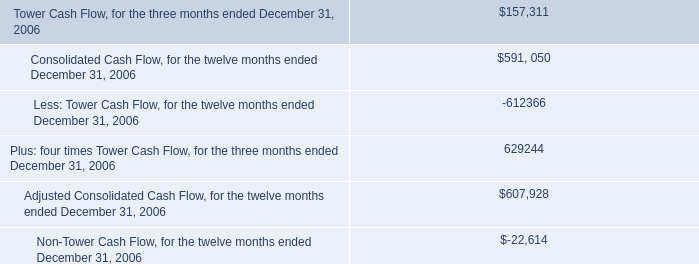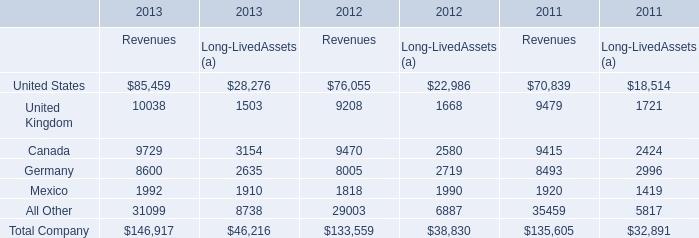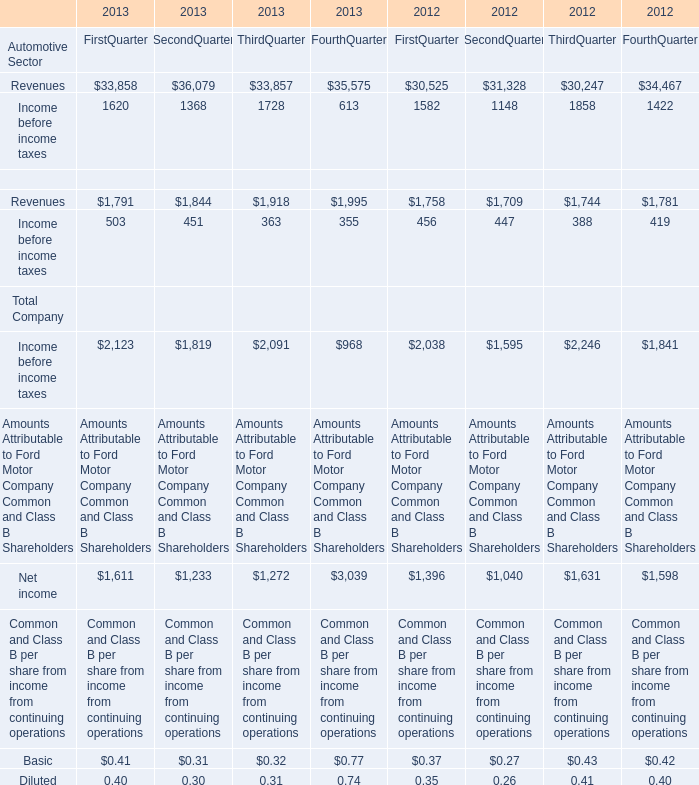Which year is the value of Revenues of Automotive Sector in the First Quarter larger? 
Answer: 2013. 